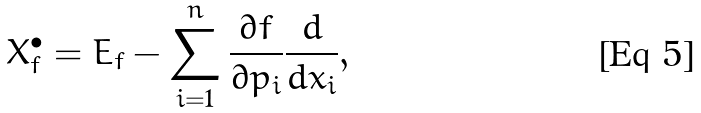<formula> <loc_0><loc_0><loc_500><loc_500>X _ { f } ^ { \bullet } = E _ { f } - \sum _ { i = 1 } ^ { n } \frac { \partial f } { \partial p _ { i } } \frac { d } { d x _ { i } } ,</formula> 